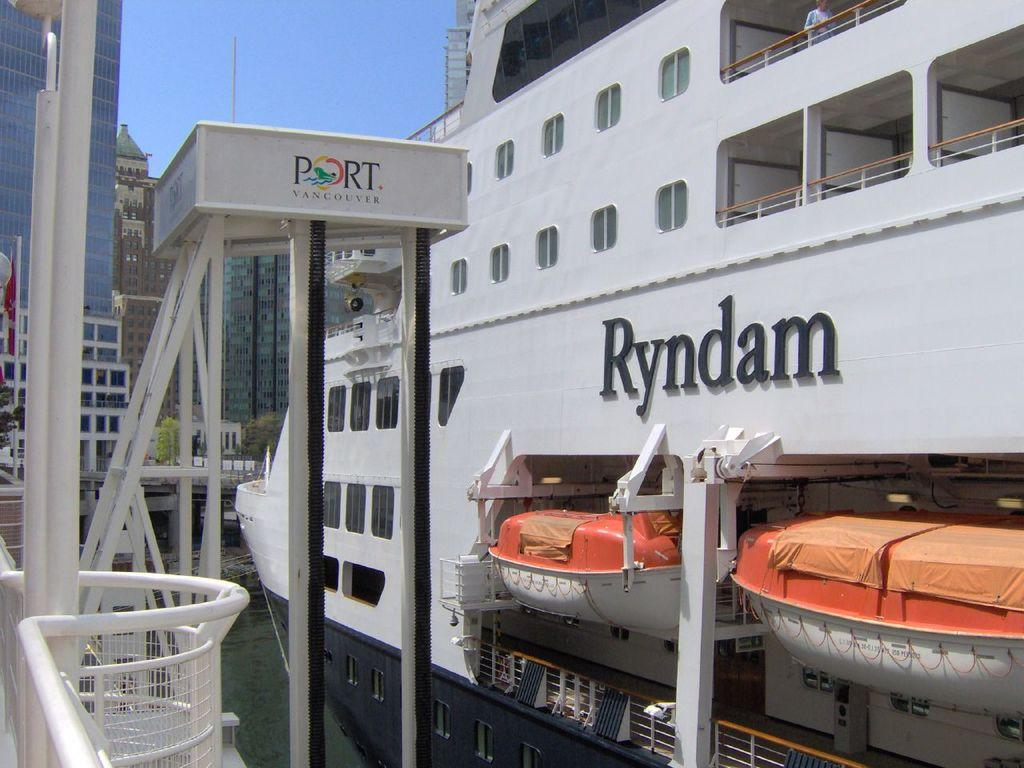<image>
Summarize the visual content of the image. the word Ryndam is above the garage with boats 